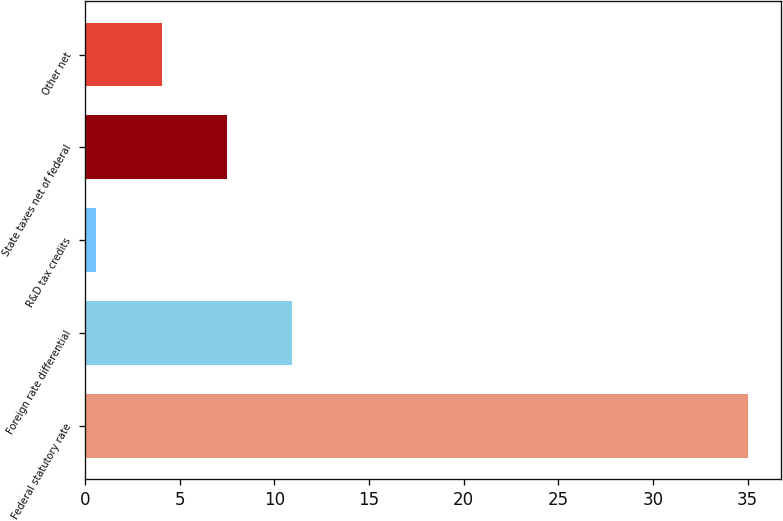Convert chart. <chart><loc_0><loc_0><loc_500><loc_500><bar_chart><fcel>Federal statutory rate<fcel>Foreign rate differential<fcel>R&D tax credits<fcel>State taxes net of federal<fcel>Other net<nl><fcel>35<fcel>10.92<fcel>0.6<fcel>7.48<fcel>4.04<nl></chart> 